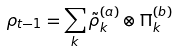<formula> <loc_0><loc_0><loc_500><loc_500>\rho _ { t - 1 } = \sum _ { k } \tilde { \rho } ^ { ( a ) } _ { k } \otimes \Pi ^ { ( b ) } _ { k }</formula> 